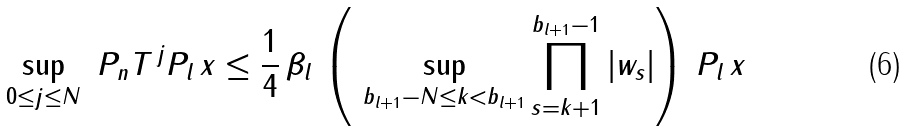Convert formula to latex. <formula><loc_0><loc_0><loc_500><loc_500>\sup _ { 0 \leq j \leq N } \ \| P _ { n } T ^ { \, j } P _ { l } \, x \| \leq \frac { 1 } { 4 } \, \beta _ { l } \, \left ( \ \sup _ { b _ { l + 1 } - N \leq k < b _ { l + 1 } } \prod _ { s = k + 1 } ^ { b _ { l + 1 } - 1 } | w _ { s } | \right ) \, \| P _ { l } \, x \|</formula> 